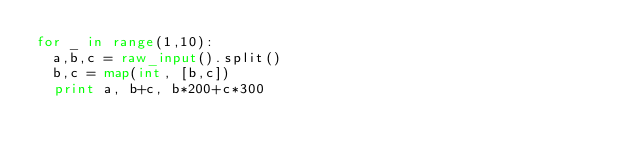<code> <loc_0><loc_0><loc_500><loc_500><_Python_>for _ in range(1,10):
  a,b,c = raw_input().split()
  b,c = map(int, [b,c])
  print a, b+c, b*200+c*300</code> 